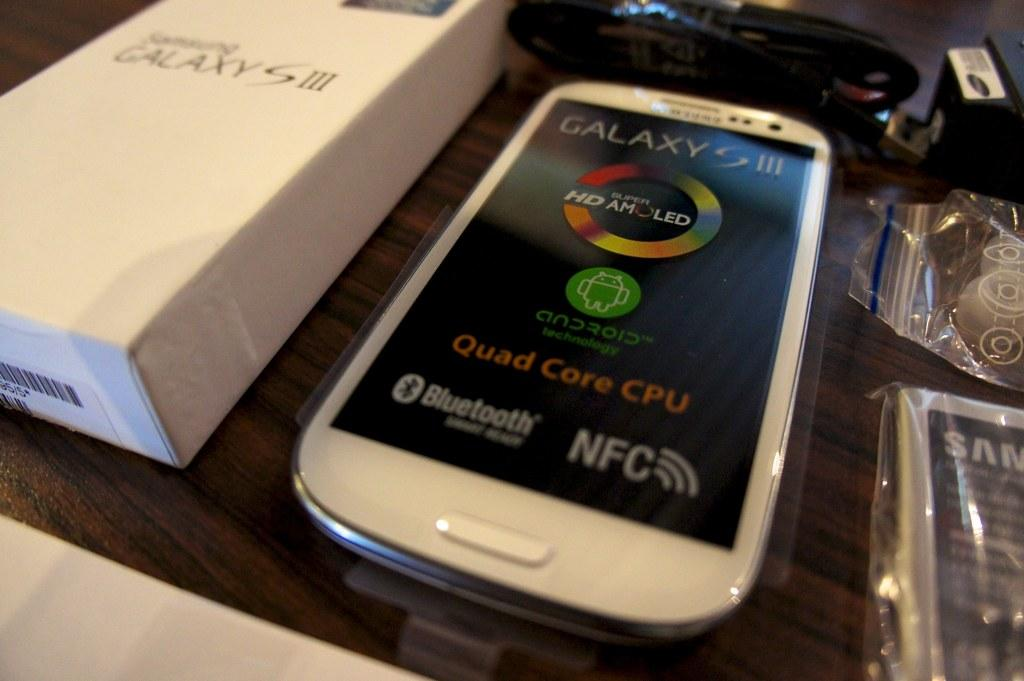<image>
Describe the image concisely. A white Galaxy S III Phone next to the box it came in. 